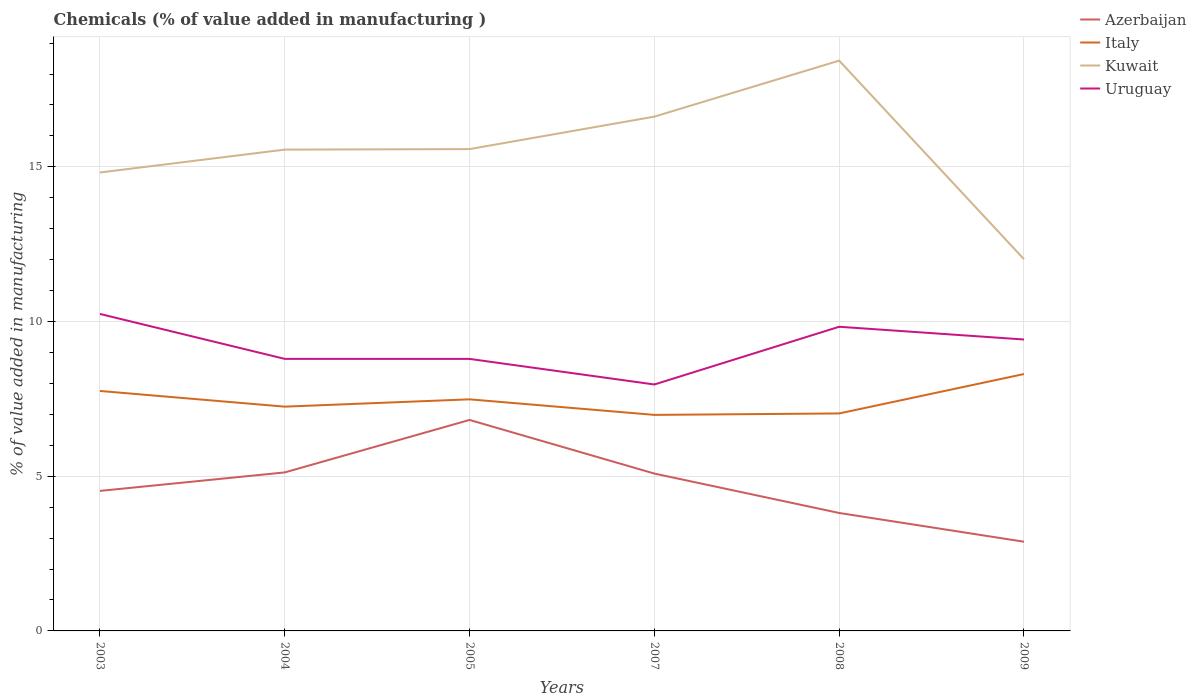How many different coloured lines are there?
Ensure brevity in your answer.  4. Does the line corresponding to Azerbaijan intersect with the line corresponding to Uruguay?
Offer a terse response. No. Across all years, what is the maximum value added in manufacturing chemicals in Kuwait?
Keep it short and to the point. 12.02. What is the total value added in manufacturing chemicals in Kuwait in the graph?
Make the answer very short. 2.8. What is the difference between the highest and the second highest value added in manufacturing chemicals in Italy?
Your response must be concise. 1.32. What is the difference between the highest and the lowest value added in manufacturing chemicals in Azerbaijan?
Offer a very short reply. 3. Is the value added in manufacturing chemicals in Kuwait strictly greater than the value added in manufacturing chemicals in Uruguay over the years?
Your response must be concise. No. How many lines are there?
Give a very brief answer. 4. What is the difference between two consecutive major ticks on the Y-axis?
Offer a very short reply. 5. Are the values on the major ticks of Y-axis written in scientific E-notation?
Ensure brevity in your answer.  No. Where does the legend appear in the graph?
Ensure brevity in your answer.  Top right. How many legend labels are there?
Give a very brief answer. 4. What is the title of the graph?
Ensure brevity in your answer.  Chemicals (% of value added in manufacturing ). Does "Lithuania" appear as one of the legend labels in the graph?
Your answer should be very brief. No. What is the label or title of the Y-axis?
Your response must be concise. % of value added in manufacturing. What is the % of value added in manufacturing of Azerbaijan in 2003?
Your response must be concise. 4.53. What is the % of value added in manufacturing in Italy in 2003?
Your answer should be compact. 7.76. What is the % of value added in manufacturing in Kuwait in 2003?
Make the answer very short. 14.82. What is the % of value added in manufacturing of Uruguay in 2003?
Provide a short and direct response. 10.25. What is the % of value added in manufacturing of Azerbaijan in 2004?
Offer a very short reply. 5.12. What is the % of value added in manufacturing of Italy in 2004?
Ensure brevity in your answer.  7.25. What is the % of value added in manufacturing in Kuwait in 2004?
Provide a short and direct response. 15.56. What is the % of value added in manufacturing in Uruguay in 2004?
Make the answer very short. 8.79. What is the % of value added in manufacturing in Azerbaijan in 2005?
Ensure brevity in your answer.  6.82. What is the % of value added in manufacturing of Italy in 2005?
Your response must be concise. 7.49. What is the % of value added in manufacturing of Kuwait in 2005?
Provide a short and direct response. 15.57. What is the % of value added in manufacturing in Uruguay in 2005?
Your answer should be very brief. 8.79. What is the % of value added in manufacturing of Azerbaijan in 2007?
Your answer should be compact. 5.09. What is the % of value added in manufacturing of Italy in 2007?
Keep it short and to the point. 6.98. What is the % of value added in manufacturing of Kuwait in 2007?
Your answer should be very brief. 16.62. What is the % of value added in manufacturing in Uruguay in 2007?
Make the answer very short. 7.97. What is the % of value added in manufacturing in Azerbaijan in 2008?
Keep it short and to the point. 3.81. What is the % of value added in manufacturing in Italy in 2008?
Keep it short and to the point. 7.03. What is the % of value added in manufacturing in Kuwait in 2008?
Make the answer very short. 18.43. What is the % of value added in manufacturing in Uruguay in 2008?
Your answer should be very brief. 9.83. What is the % of value added in manufacturing in Azerbaijan in 2009?
Your answer should be compact. 2.88. What is the % of value added in manufacturing of Italy in 2009?
Your response must be concise. 8.3. What is the % of value added in manufacturing of Kuwait in 2009?
Provide a short and direct response. 12.02. What is the % of value added in manufacturing in Uruguay in 2009?
Make the answer very short. 9.42. Across all years, what is the maximum % of value added in manufacturing in Azerbaijan?
Your answer should be very brief. 6.82. Across all years, what is the maximum % of value added in manufacturing in Italy?
Make the answer very short. 8.3. Across all years, what is the maximum % of value added in manufacturing of Kuwait?
Keep it short and to the point. 18.43. Across all years, what is the maximum % of value added in manufacturing of Uruguay?
Your answer should be very brief. 10.25. Across all years, what is the minimum % of value added in manufacturing in Azerbaijan?
Provide a short and direct response. 2.88. Across all years, what is the minimum % of value added in manufacturing of Italy?
Your answer should be very brief. 6.98. Across all years, what is the minimum % of value added in manufacturing of Kuwait?
Give a very brief answer. 12.02. Across all years, what is the minimum % of value added in manufacturing of Uruguay?
Offer a terse response. 7.97. What is the total % of value added in manufacturing in Azerbaijan in the graph?
Make the answer very short. 28.25. What is the total % of value added in manufacturing in Italy in the graph?
Give a very brief answer. 44.81. What is the total % of value added in manufacturing in Kuwait in the graph?
Provide a short and direct response. 93.02. What is the total % of value added in manufacturing in Uruguay in the graph?
Provide a succinct answer. 55.05. What is the difference between the % of value added in manufacturing of Azerbaijan in 2003 and that in 2004?
Ensure brevity in your answer.  -0.6. What is the difference between the % of value added in manufacturing in Italy in 2003 and that in 2004?
Give a very brief answer. 0.51. What is the difference between the % of value added in manufacturing in Kuwait in 2003 and that in 2004?
Ensure brevity in your answer.  -0.74. What is the difference between the % of value added in manufacturing in Uruguay in 2003 and that in 2004?
Your answer should be compact. 1.45. What is the difference between the % of value added in manufacturing of Azerbaijan in 2003 and that in 2005?
Your answer should be compact. -2.29. What is the difference between the % of value added in manufacturing in Italy in 2003 and that in 2005?
Your response must be concise. 0.27. What is the difference between the % of value added in manufacturing in Kuwait in 2003 and that in 2005?
Offer a terse response. -0.76. What is the difference between the % of value added in manufacturing of Uruguay in 2003 and that in 2005?
Ensure brevity in your answer.  1.45. What is the difference between the % of value added in manufacturing of Azerbaijan in 2003 and that in 2007?
Offer a terse response. -0.56. What is the difference between the % of value added in manufacturing in Italy in 2003 and that in 2007?
Make the answer very short. 0.77. What is the difference between the % of value added in manufacturing in Kuwait in 2003 and that in 2007?
Offer a very short reply. -1.81. What is the difference between the % of value added in manufacturing in Uruguay in 2003 and that in 2007?
Offer a terse response. 2.28. What is the difference between the % of value added in manufacturing in Azerbaijan in 2003 and that in 2008?
Your answer should be very brief. 0.71. What is the difference between the % of value added in manufacturing in Italy in 2003 and that in 2008?
Give a very brief answer. 0.73. What is the difference between the % of value added in manufacturing in Kuwait in 2003 and that in 2008?
Your answer should be very brief. -3.62. What is the difference between the % of value added in manufacturing of Uruguay in 2003 and that in 2008?
Provide a succinct answer. 0.41. What is the difference between the % of value added in manufacturing in Azerbaijan in 2003 and that in 2009?
Make the answer very short. 1.64. What is the difference between the % of value added in manufacturing of Italy in 2003 and that in 2009?
Offer a very short reply. -0.55. What is the difference between the % of value added in manufacturing in Kuwait in 2003 and that in 2009?
Your answer should be compact. 2.8. What is the difference between the % of value added in manufacturing in Uruguay in 2003 and that in 2009?
Your response must be concise. 0.83. What is the difference between the % of value added in manufacturing of Azerbaijan in 2004 and that in 2005?
Offer a terse response. -1.7. What is the difference between the % of value added in manufacturing of Italy in 2004 and that in 2005?
Keep it short and to the point. -0.24. What is the difference between the % of value added in manufacturing in Kuwait in 2004 and that in 2005?
Offer a very short reply. -0.02. What is the difference between the % of value added in manufacturing of Uruguay in 2004 and that in 2005?
Provide a short and direct response. 0. What is the difference between the % of value added in manufacturing in Azerbaijan in 2004 and that in 2007?
Offer a very short reply. 0.04. What is the difference between the % of value added in manufacturing in Italy in 2004 and that in 2007?
Ensure brevity in your answer.  0.27. What is the difference between the % of value added in manufacturing in Kuwait in 2004 and that in 2007?
Offer a very short reply. -1.07. What is the difference between the % of value added in manufacturing of Uruguay in 2004 and that in 2007?
Keep it short and to the point. 0.83. What is the difference between the % of value added in manufacturing of Azerbaijan in 2004 and that in 2008?
Offer a terse response. 1.31. What is the difference between the % of value added in manufacturing in Italy in 2004 and that in 2008?
Offer a terse response. 0.22. What is the difference between the % of value added in manufacturing in Kuwait in 2004 and that in 2008?
Make the answer very short. -2.88. What is the difference between the % of value added in manufacturing of Uruguay in 2004 and that in 2008?
Provide a succinct answer. -1.04. What is the difference between the % of value added in manufacturing in Azerbaijan in 2004 and that in 2009?
Provide a short and direct response. 2.24. What is the difference between the % of value added in manufacturing of Italy in 2004 and that in 2009?
Offer a very short reply. -1.05. What is the difference between the % of value added in manufacturing of Kuwait in 2004 and that in 2009?
Your answer should be compact. 3.54. What is the difference between the % of value added in manufacturing in Uruguay in 2004 and that in 2009?
Provide a short and direct response. -0.63. What is the difference between the % of value added in manufacturing of Azerbaijan in 2005 and that in 2007?
Keep it short and to the point. 1.73. What is the difference between the % of value added in manufacturing in Italy in 2005 and that in 2007?
Your answer should be very brief. 0.5. What is the difference between the % of value added in manufacturing of Kuwait in 2005 and that in 2007?
Provide a short and direct response. -1.05. What is the difference between the % of value added in manufacturing of Uruguay in 2005 and that in 2007?
Offer a very short reply. 0.83. What is the difference between the % of value added in manufacturing of Azerbaijan in 2005 and that in 2008?
Your answer should be compact. 3.01. What is the difference between the % of value added in manufacturing in Italy in 2005 and that in 2008?
Make the answer very short. 0.46. What is the difference between the % of value added in manufacturing of Kuwait in 2005 and that in 2008?
Your answer should be very brief. -2.86. What is the difference between the % of value added in manufacturing in Uruguay in 2005 and that in 2008?
Your answer should be very brief. -1.04. What is the difference between the % of value added in manufacturing in Azerbaijan in 2005 and that in 2009?
Provide a short and direct response. 3.94. What is the difference between the % of value added in manufacturing in Italy in 2005 and that in 2009?
Provide a short and direct response. -0.82. What is the difference between the % of value added in manufacturing in Kuwait in 2005 and that in 2009?
Give a very brief answer. 3.56. What is the difference between the % of value added in manufacturing of Uruguay in 2005 and that in 2009?
Keep it short and to the point. -0.63. What is the difference between the % of value added in manufacturing of Azerbaijan in 2007 and that in 2008?
Make the answer very short. 1.27. What is the difference between the % of value added in manufacturing in Italy in 2007 and that in 2008?
Provide a succinct answer. -0.05. What is the difference between the % of value added in manufacturing of Kuwait in 2007 and that in 2008?
Make the answer very short. -1.81. What is the difference between the % of value added in manufacturing of Uruguay in 2007 and that in 2008?
Offer a very short reply. -1.87. What is the difference between the % of value added in manufacturing in Azerbaijan in 2007 and that in 2009?
Your answer should be compact. 2.2. What is the difference between the % of value added in manufacturing of Italy in 2007 and that in 2009?
Make the answer very short. -1.32. What is the difference between the % of value added in manufacturing of Kuwait in 2007 and that in 2009?
Ensure brevity in your answer.  4.61. What is the difference between the % of value added in manufacturing in Uruguay in 2007 and that in 2009?
Your response must be concise. -1.45. What is the difference between the % of value added in manufacturing in Azerbaijan in 2008 and that in 2009?
Your response must be concise. 0.93. What is the difference between the % of value added in manufacturing in Italy in 2008 and that in 2009?
Your response must be concise. -1.27. What is the difference between the % of value added in manufacturing in Kuwait in 2008 and that in 2009?
Give a very brief answer. 6.42. What is the difference between the % of value added in manufacturing of Uruguay in 2008 and that in 2009?
Offer a terse response. 0.41. What is the difference between the % of value added in manufacturing of Azerbaijan in 2003 and the % of value added in manufacturing of Italy in 2004?
Your answer should be compact. -2.72. What is the difference between the % of value added in manufacturing in Azerbaijan in 2003 and the % of value added in manufacturing in Kuwait in 2004?
Provide a short and direct response. -11.03. What is the difference between the % of value added in manufacturing of Azerbaijan in 2003 and the % of value added in manufacturing of Uruguay in 2004?
Your answer should be very brief. -4.27. What is the difference between the % of value added in manufacturing of Italy in 2003 and the % of value added in manufacturing of Kuwait in 2004?
Offer a terse response. -7.8. What is the difference between the % of value added in manufacturing in Italy in 2003 and the % of value added in manufacturing in Uruguay in 2004?
Give a very brief answer. -1.04. What is the difference between the % of value added in manufacturing of Kuwait in 2003 and the % of value added in manufacturing of Uruguay in 2004?
Keep it short and to the point. 6.02. What is the difference between the % of value added in manufacturing of Azerbaijan in 2003 and the % of value added in manufacturing of Italy in 2005?
Give a very brief answer. -2.96. What is the difference between the % of value added in manufacturing of Azerbaijan in 2003 and the % of value added in manufacturing of Kuwait in 2005?
Give a very brief answer. -11.05. What is the difference between the % of value added in manufacturing in Azerbaijan in 2003 and the % of value added in manufacturing in Uruguay in 2005?
Give a very brief answer. -4.27. What is the difference between the % of value added in manufacturing of Italy in 2003 and the % of value added in manufacturing of Kuwait in 2005?
Make the answer very short. -7.82. What is the difference between the % of value added in manufacturing in Italy in 2003 and the % of value added in manufacturing in Uruguay in 2005?
Ensure brevity in your answer.  -1.04. What is the difference between the % of value added in manufacturing in Kuwait in 2003 and the % of value added in manufacturing in Uruguay in 2005?
Give a very brief answer. 6.03. What is the difference between the % of value added in manufacturing in Azerbaijan in 2003 and the % of value added in manufacturing in Italy in 2007?
Offer a terse response. -2.46. What is the difference between the % of value added in manufacturing in Azerbaijan in 2003 and the % of value added in manufacturing in Kuwait in 2007?
Provide a succinct answer. -12.1. What is the difference between the % of value added in manufacturing in Azerbaijan in 2003 and the % of value added in manufacturing in Uruguay in 2007?
Make the answer very short. -3.44. What is the difference between the % of value added in manufacturing of Italy in 2003 and the % of value added in manufacturing of Kuwait in 2007?
Keep it short and to the point. -8.87. What is the difference between the % of value added in manufacturing in Italy in 2003 and the % of value added in manufacturing in Uruguay in 2007?
Offer a very short reply. -0.21. What is the difference between the % of value added in manufacturing in Kuwait in 2003 and the % of value added in manufacturing in Uruguay in 2007?
Provide a short and direct response. 6.85. What is the difference between the % of value added in manufacturing of Azerbaijan in 2003 and the % of value added in manufacturing of Italy in 2008?
Offer a very short reply. -2.5. What is the difference between the % of value added in manufacturing of Azerbaijan in 2003 and the % of value added in manufacturing of Kuwait in 2008?
Make the answer very short. -13.91. What is the difference between the % of value added in manufacturing of Azerbaijan in 2003 and the % of value added in manufacturing of Uruguay in 2008?
Your response must be concise. -5.31. What is the difference between the % of value added in manufacturing in Italy in 2003 and the % of value added in manufacturing in Kuwait in 2008?
Your response must be concise. -10.68. What is the difference between the % of value added in manufacturing of Italy in 2003 and the % of value added in manufacturing of Uruguay in 2008?
Give a very brief answer. -2.08. What is the difference between the % of value added in manufacturing of Kuwait in 2003 and the % of value added in manufacturing of Uruguay in 2008?
Provide a succinct answer. 4.99. What is the difference between the % of value added in manufacturing of Azerbaijan in 2003 and the % of value added in manufacturing of Italy in 2009?
Your response must be concise. -3.78. What is the difference between the % of value added in manufacturing in Azerbaijan in 2003 and the % of value added in manufacturing in Kuwait in 2009?
Keep it short and to the point. -7.49. What is the difference between the % of value added in manufacturing in Azerbaijan in 2003 and the % of value added in manufacturing in Uruguay in 2009?
Your answer should be very brief. -4.89. What is the difference between the % of value added in manufacturing of Italy in 2003 and the % of value added in manufacturing of Kuwait in 2009?
Your answer should be compact. -4.26. What is the difference between the % of value added in manufacturing in Italy in 2003 and the % of value added in manufacturing in Uruguay in 2009?
Your answer should be very brief. -1.66. What is the difference between the % of value added in manufacturing of Kuwait in 2003 and the % of value added in manufacturing of Uruguay in 2009?
Your response must be concise. 5.4. What is the difference between the % of value added in manufacturing in Azerbaijan in 2004 and the % of value added in manufacturing in Italy in 2005?
Your response must be concise. -2.36. What is the difference between the % of value added in manufacturing in Azerbaijan in 2004 and the % of value added in manufacturing in Kuwait in 2005?
Offer a very short reply. -10.45. What is the difference between the % of value added in manufacturing of Azerbaijan in 2004 and the % of value added in manufacturing of Uruguay in 2005?
Provide a succinct answer. -3.67. What is the difference between the % of value added in manufacturing of Italy in 2004 and the % of value added in manufacturing of Kuwait in 2005?
Your answer should be very brief. -8.33. What is the difference between the % of value added in manufacturing in Italy in 2004 and the % of value added in manufacturing in Uruguay in 2005?
Your answer should be very brief. -1.54. What is the difference between the % of value added in manufacturing in Kuwait in 2004 and the % of value added in manufacturing in Uruguay in 2005?
Your answer should be compact. 6.77. What is the difference between the % of value added in manufacturing of Azerbaijan in 2004 and the % of value added in manufacturing of Italy in 2007?
Offer a very short reply. -1.86. What is the difference between the % of value added in manufacturing of Azerbaijan in 2004 and the % of value added in manufacturing of Kuwait in 2007?
Your answer should be very brief. -11.5. What is the difference between the % of value added in manufacturing in Azerbaijan in 2004 and the % of value added in manufacturing in Uruguay in 2007?
Provide a succinct answer. -2.84. What is the difference between the % of value added in manufacturing of Italy in 2004 and the % of value added in manufacturing of Kuwait in 2007?
Give a very brief answer. -9.37. What is the difference between the % of value added in manufacturing in Italy in 2004 and the % of value added in manufacturing in Uruguay in 2007?
Provide a succinct answer. -0.72. What is the difference between the % of value added in manufacturing of Kuwait in 2004 and the % of value added in manufacturing of Uruguay in 2007?
Your answer should be very brief. 7.59. What is the difference between the % of value added in manufacturing of Azerbaijan in 2004 and the % of value added in manufacturing of Italy in 2008?
Provide a short and direct response. -1.91. What is the difference between the % of value added in manufacturing of Azerbaijan in 2004 and the % of value added in manufacturing of Kuwait in 2008?
Ensure brevity in your answer.  -13.31. What is the difference between the % of value added in manufacturing of Azerbaijan in 2004 and the % of value added in manufacturing of Uruguay in 2008?
Keep it short and to the point. -4.71. What is the difference between the % of value added in manufacturing in Italy in 2004 and the % of value added in manufacturing in Kuwait in 2008?
Offer a terse response. -11.18. What is the difference between the % of value added in manufacturing in Italy in 2004 and the % of value added in manufacturing in Uruguay in 2008?
Make the answer very short. -2.58. What is the difference between the % of value added in manufacturing of Kuwait in 2004 and the % of value added in manufacturing of Uruguay in 2008?
Your answer should be compact. 5.73. What is the difference between the % of value added in manufacturing in Azerbaijan in 2004 and the % of value added in manufacturing in Italy in 2009?
Make the answer very short. -3.18. What is the difference between the % of value added in manufacturing in Azerbaijan in 2004 and the % of value added in manufacturing in Kuwait in 2009?
Offer a very short reply. -6.89. What is the difference between the % of value added in manufacturing in Azerbaijan in 2004 and the % of value added in manufacturing in Uruguay in 2009?
Provide a succinct answer. -4.3. What is the difference between the % of value added in manufacturing of Italy in 2004 and the % of value added in manufacturing of Kuwait in 2009?
Ensure brevity in your answer.  -4.77. What is the difference between the % of value added in manufacturing in Italy in 2004 and the % of value added in manufacturing in Uruguay in 2009?
Your response must be concise. -2.17. What is the difference between the % of value added in manufacturing of Kuwait in 2004 and the % of value added in manufacturing of Uruguay in 2009?
Offer a terse response. 6.14. What is the difference between the % of value added in manufacturing of Azerbaijan in 2005 and the % of value added in manufacturing of Italy in 2007?
Keep it short and to the point. -0.16. What is the difference between the % of value added in manufacturing of Azerbaijan in 2005 and the % of value added in manufacturing of Kuwait in 2007?
Your response must be concise. -9.8. What is the difference between the % of value added in manufacturing of Azerbaijan in 2005 and the % of value added in manufacturing of Uruguay in 2007?
Your answer should be compact. -1.15. What is the difference between the % of value added in manufacturing of Italy in 2005 and the % of value added in manufacturing of Kuwait in 2007?
Provide a short and direct response. -9.14. What is the difference between the % of value added in manufacturing of Italy in 2005 and the % of value added in manufacturing of Uruguay in 2007?
Ensure brevity in your answer.  -0.48. What is the difference between the % of value added in manufacturing of Kuwait in 2005 and the % of value added in manufacturing of Uruguay in 2007?
Offer a very short reply. 7.61. What is the difference between the % of value added in manufacturing of Azerbaijan in 2005 and the % of value added in manufacturing of Italy in 2008?
Provide a succinct answer. -0.21. What is the difference between the % of value added in manufacturing in Azerbaijan in 2005 and the % of value added in manufacturing in Kuwait in 2008?
Offer a terse response. -11.61. What is the difference between the % of value added in manufacturing in Azerbaijan in 2005 and the % of value added in manufacturing in Uruguay in 2008?
Your response must be concise. -3.01. What is the difference between the % of value added in manufacturing of Italy in 2005 and the % of value added in manufacturing of Kuwait in 2008?
Offer a terse response. -10.95. What is the difference between the % of value added in manufacturing in Italy in 2005 and the % of value added in manufacturing in Uruguay in 2008?
Make the answer very short. -2.35. What is the difference between the % of value added in manufacturing of Kuwait in 2005 and the % of value added in manufacturing of Uruguay in 2008?
Provide a short and direct response. 5.74. What is the difference between the % of value added in manufacturing of Azerbaijan in 2005 and the % of value added in manufacturing of Italy in 2009?
Give a very brief answer. -1.48. What is the difference between the % of value added in manufacturing of Azerbaijan in 2005 and the % of value added in manufacturing of Kuwait in 2009?
Make the answer very short. -5.2. What is the difference between the % of value added in manufacturing in Azerbaijan in 2005 and the % of value added in manufacturing in Uruguay in 2009?
Your response must be concise. -2.6. What is the difference between the % of value added in manufacturing of Italy in 2005 and the % of value added in manufacturing of Kuwait in 2009?
Provide a short and direct response. -4.53. What is the difference between the % of value added in manufacturing of Italy in 2005 and the % of value added in manufacturing of Uruguay in 2009?
Keep it short and to the point. -1.93. What is the difference between the % of value added in manufacturing of Kuwait in 2005 and the % of value added in manufacturing of Uruguay in 2009?
Your answer should be very brief. 6.15. What is the difference between the % of value added in manufacturing in Azerbaijan in 2007 and the % of value added in manufacturing in Italy in 2008?
Keep it short and to the point. -1.94. What is the difference between the % of value added in manufacturing of Azerbaijan in 2007 and the % of value added in manufacturing of Kuwait in 2008?
Offer a very short reply. -13.35. What is the difference between the % of value added in manufacturing in Azerbaijan in 2007 and the % of value added in manufacturing in Uruguay in 2008?
Provide a short and direct response. -4.74. What is the difference between the % of value added in manufacturing in Italy in 2007 and the % of value added in manufacturing in Kuwait in 2008?
Your response must be concise. -11.45. What is the difference between the % of value added in manufacturing in Italy in 2007 and the % of value added in manufacturing in Uruguay in 2008?
Provide a short and direct response. -2.85. What is the difference between the % of value added in manufacturing in Kuwait in 2007 and the % of value added in manufacturing in Uruguay in 2008?
Keep it short and to the point. 6.79. What is the difference between the % of value added in manufacturing of Azerbaijan in 2007 and the % of value added in manufacturing of Italy in 2009?
Give a very brief answer. -3.22. What is the difference between the % of value added in manufacturing of Azerbaijan in 2007 and the % of value added in manufacturing of Kuwait in 2009?
Give a very brief answer. -6.93. What is the difference between the % of value added in manufacturing of Azerbaijan in 2007 and the % of value added in manufacturing of Uruguay in 2009?
Your response must be concise. -4.33. What is the difference between the % of value added in manufacturing in Italy in 2007 and the % of value added in manufacturing in Kuwait in 2009?
Ensure brevity in your answer.  -5.03. What is the difference between the % of value added in manufacturing in Italy in 2007 and the % of value added in manufacturing in Uruguay in 2009?
Your answer should be very brief. -2.44. What is the difference between the % of value added in manufacturing of Kuwait in 2007 and the % of value added in manufacturing of Uruguay in 2009?
Give a very brief answer. 7.2. What is the difference between the % of value added in manufacturing in Azerbaijan in 2008 and the % of value added in manufacturing in Italy in 2009?
Offer a very short reply. -4.49. What is the difference between the % of value added in manufacturing in Azerbaijan in 2008 and the % of value added in manufacturing in Kuwait in 2009?
Provide a succinct answer. -8.2. What is the difference between the % of value added in manufacturing in Azerbaijan in 2008 and the % of value added in manufacturing in Uruguay in 2009?
Your answer should be compact. -5.61. What is the difference between the % of value added in manufacturing in Italy in 2008 and the % of value added in manufacturing in Kuwait in 2009?
Offer a terse response. -4.99. What is the difference between the % of value added in manufacturing of Italy in 2008 and the % of value added in manufacturing of Uruguay in 2009?
Provide a succinct answer. -2.39. What is the difference between the % of value added in manufacturing in Kuwait in 2008 and the % of value added in manufacturing in Uruguay in 2009?
Offer a very short reply. 9.01. What is the average % of value added in manufacturing of Azerbaijan per year?
Offer a terse response. 4.71. What is the average % of value added in manufacturing of Italy per year?
Provide a short and direct response. 7.47. What is the average % of value added in manufacturing of Kuwait per year?
Offer a very short reply. 15.5. What is the average % of value added in manufacturing of Uruguay per year?
Ensure brevity in your answer.  9.17. In the year 2003, what is the difference between the % of value added in manufacturing in Azerbaijan and % of value added in manufacturing in Italy?
Your answer should be very brief. -3.23. In the year 2003, what is the difference between the % of value added in manufacturing of Azerbaijan and % of value added in manufacturing of Kuwait?
Offer a very short reply. -10.29. In the year 2003, what is the difference between the % of value added in manufacturing in Azerbaijan and % of value added in manufacturing in Uruguay?
Your answer should be very brief. -5.72. In the year 2003, what is the difference between the % of value added in manufacturing in Italy and % of value added in manufacturing in Kuwait?
Keep it short and to the point. -7.06. In the year 2003, what is the difference between the % of value added in manufacturing in Italy and % of value added in manufacturing in Uruguay?
Make the answer very short. -2.49. In the year 2003, what is the difference between the % of value added in manufacturing in Kuwait and % of value added in manufacturing in Uruguay?
Your response must be concise. 4.57. In the year 2004, what is the difference between the % of value added in manufacturing of Azerbaijan and % of value added in manufacturing of Italy?
Make the answer very short. -2.13. In the year 2004, what is the difference between the % of value added in manufacturing of Azerbaijan and % of value added in manufacturing of Kuwait?
Offer a terse response. -10.43. In the year 2004, what is the difference between the % of value added in manufacturing of Azerbaijan and % of value added in manufacturing of Uruguay?
Provide a succinct answer. -3.67. In the year 2004, what is the difference between the % of value added in manufacturing in Italy and % of value added in manufacturing in Kuwait?
Ensure brevity in your answer.  -8.31. In the year 2004, what is the difference between the % of value added in manufacturing of Italy and % of value added in manufacturing of Uruguay?
Ensure brevity in your answer.  -1.54. In the year 2004, what is the difference between the % of value added in manufacturing of Kuwait and % of value added in manufacturing of Uruguay?
Your response must be concise. 6.76. In the year 2005, what is the difference between the % of value added in manufacturing in Azerbaijan and % of value added in manufacturing in Italy?
Provide a short and direct response. -0.67. In the year 2005, what is the difference between the % of value added in manufacturing of Azerbaijan and % of value added in manufacturing of Kuwait?
Your answer should be very brief. -8.76. In the year 2005, what is the difference between the % of value added in manufacturing of Azerbaijan and % of value added in manufacturing of Uruguay?
Offer a very short reply. -1.97. In the year 2005, what is the difference between the % of value added in manufacturing in Italy and % of value added in manufacturing in Kuwait?
Your answer should be compact. -8.09. In the year 2005, what is the difference between the % of value added in manufacturing of Italy and % of value added in manufacturing of Uruguay?
Your answer should be compact. -1.31. In the year 2005, what is the difference between the % of value added in manufacturing in Kuwait and % of value added in manufacturing in Uruguay?
Keep it short and to the point. 6.78. In the year 2007, what is the difference between the % of value added in manufacturing in Azerbaijan and % of value added in manufacturing in Italy?
Provide a short and direct response. -1.9. In the year 2007, what is the difference between the % of value added in manufacturing of Azerbaijan and % of value added in manufacturing of Kuwait?
Provide a short and direct response. -11.54. In the year 2007, what is the difference between the % of value added in manufacturing of Azerbaijan and % of value added in manufacturing of Uruguay?
Your answer should be very brief. -2.88. In the year 2007, what is the difference between the % of value added in manufacturing in Italy and % of value added in manufacturing in Kuwait?
Provide a short and direct response. -9.64. In the year 2007, what is the difference between the % of value added in manufacturing of Italy and % of value added in manufacturing of Uruguay?
Provide a succinct answer. -0.98. In the year 2007, what is the difference between the % of value added in manufacturing of Kuwait and % of value added in manufacturing of Uruguay?
Keep it short and to the point. 8.66. In the year 2008, what is the difference between the % of value added in manufacturing in Azerbaijan and % of value added in manufacturing in Italy?
Your answer should be very brief. -3.22. In the year 2008, what is the difference between the % of value added in manufacturing of Azerbaijan and % of value added in manufacturing of Kuwait?
Provide a succinct answer. -14.62. In the year 2008, what is the difference between the % of value added in manufacturing in Azerbaijan and % of value added in manufacturing in Uruguay?
Give a very brief answer. -6.02. In the year 2008, what is the difference between the % of value added in manufacturing in Italy and % of value added in manufacturing in Kuwait?
Give a very brief answer. -11.4. In the year 2008, what is the difference between the % of value added in manufacturing of Italy and % of value added in manufacturing of Uruguay?
Ensure brevity in your answer.  -2.8. In the year 2008, what is the difference between the % of value added in manufacturing in Kuwait and % of value added in manufacturing in Uruguay?
Give a very brief answer. 8.6. In the year 2009, what is the difference between the % of value added in manufacturing in Azerbaijan and % of value added in manufacturing in Italy?
Your response must be concise. -5.42. In the year 2009, what is the difference between the % of value added in manufacturing in Azerbaijan and % of value added in manufacturing in Kuwait?
Keep it short and to the point. -9.13. In the year 2009, what is the difference between the % of value added in manufacturing in Azerbaijan and % of value added in manufacturing in Uruguay?
Your response must be concise. -6.54. In the year 2009, what is the difference between the % of value added in manufacturing of Italy and % of value added in manufacturing of Kuwait?
Make the answer very short. -3.71. In the year 2009, what is the difference between the % of value added in manufacturing in Italy and % of value added in manufacturing in Uruguay?
Ensure brevity in your answer.  -1.12. In the year 2009, what is the difference between the % of value added in manufacturing of Kuwait and % of value added in manufacturing of Uruguay?
Ensure brevity in your answer.  2.6. What is the ratio of the % of value added in manufacturing in Azerbaijan in 2003 to that in 2004?
Provide a succinct answer. 0.88. What is the ratio of the % of value added in manufacturing in Italy in 2003 to that in 2004?
Offer a very short reply. 1.07. What is the ratio of the % of value added in manufacturing in Kuwait in 2003 to that in 2004?
Offer a terse response. 0.95. What is the ratio of the % of value added in manufacturing in Uruguay in 2003 to that in 2004?
Your response must be concise. 1.17. What is the ratio of the % of value added in manufacturing of Azerbaijan in 2003 to that in 2005?
Give a very brief answer. 0.66. What is the ratio of the % of value added in manufacturing of Italy in 2003 to that in 2005?
Your response must be concise. 1.04. What is the ratio of the % of value added in manufacturing in Kuwait in 2003 to that in 2005?
Make the answer very short. 0.95. What is the ratio of the % of value added in manufacturing of Uruguay in 2003 to that in 2005?
Your answer should be very brief. 1.17. What is the ratio of the % of value added in manufacturing in Azerbaijan in 2003 to that in 2007?
Offer a terse response. 0.89. What is the ratio of the % of value added in manufacturing in Italy in 2003 to that in 2007?
Offer a very short reply. 1.11. What is the ratio of the % of value added in manufacturing in Kuwait in 2003 to that in 2007?
Offer a terse response. 0.89. What is the ratio of the % of value added in manufacturing in Uruguay in 2003 to that in 2007?
Your response must be concise. 1.29. What is the ratio of the % of value added in manufacturing of Azerbaijan in 2003 to that in 2008?
Ensure brevity in your answer.  1.19. What is the ratio of the % of value added in manufacturing of Italy in 2003 to that in 2008?
Provide a short and direct response. 1.1. What is the ratio of the % of value added in manufacturing in Kuwait in 2003 to that in 2008?
Give a very brief answer. 0.8. What is the ratio of the % of value added in manufacturing in Uruguay in 2003 to that in 2008?
Keep it short and to the point. 1.04. What is the ratio of the % of value added in manufacturing of Azerbaijan in 2003 to that in 2009?
Keep it short and to the point. 1.57. What is the ratio of the % of value added in manufacturing in Italy in 2003 to that in 2009?
Offer a terse response. 0.93. What is the ratio of the % of value added in manufacturing in Kuwait in 2003 to that in 2009?
Your answer should be compact. 1.23. What is the ratio of the % of value added in manufacturing in Uruguay in 2003 to that in 2009?
Keep it short and to the point. 1.09. What is the ratio of the % of value added in manufacturing of Azerbaijan in 2004 to that in 2005?
Provide a succinct answer. 0.75. What is the ratio of the % of value added in manufacturing of Italy in 2004 to that in 2005?
Keep it short and to the point. 0.97. What is the ratio of the % of value added in manufacturing in Italy in 2004 to that in 2007?
Offer a terse response. 1.04. What is the ratio of the % of value added in manufacturing in Kuwait in 2004 to that in 2007?
Make the answer very short. 0.94. What is the ratio of the % of value added in manufacturing in Uruguay in 2004 to that in 2007?
Your answer should be compact. 1.1. What is the ratio of the % of value added in manufacturing in Azerbaijan in 2004 to that in 2008?
Offer a very short reply. 1.34. What is the ratio of the % of value added in manufacturing in Italy in 2004 to that in 2008?
Offer a terse response. 1.03. What is the ratio of the % of value added in manufacturing of Kuwait in 2004 to that in 2008?
Give a very brief answer. 0.84. What is the ratio of the % of value added in manufacturing in Uruguay in 2004 to that in 2008?
Offer a terse response. 0.89. What is the ratio of the % of value added in manufacturing of Azerbaijan in 2004 to that in 2009?
Provide a succinct answer. 1.78. What is the ratio of the % of value added in manufacturing in Italy in 2004 to that in 2009?
Your answer should be very brief. 0.87. What is the ratio of the % of value added in manufacturing in Kuwait in 2004 to that in 2009?
Provide a short and direct response. 1.29. What is the ratio of the % of value added in manufacturing of Uruguay in 2004 to that in 2009?
Provide a short and direct response. 0.93. What is the ratio of the % of value added in manufacturing in Azerbaijan in 2005 to that in 2007?
Make the answer very short. 1.34. What is the ratio of the % of value added in manufacturing of Italy in 2005 to that in 2007?
Offer a terse response. 1.07. What is the ratio of the % of value added in manufacturing of Kuwait in 2005 to that in 2007?
Provide a succinct answer. 0.94. What is the ratio of the % of value added in manufacturing of Uruguay in 2005 to that in 2007?
Provide a succinct answer. 1.1. What is the ratio of the % of value added in manufacturing in Azerbaijan in 2005 to that in 2008?
Offer a very short reply. 1.79. What is the ratio of the % of value added in manufacturing in Italy in 2005 to that in 2008?
Your answer should be compact. 1.06. What is the ratio of the % of value added in manufacturing in Kuwait in 2005 to that in 2008?
Provide a short and direct response. 0.84. What is the ratio of the % of value added in manufacturing in Uruguay in 2005 to that in 2008?
Make the answer very short. 0.89. What is the ratio of the % of value added in manufacturing in Azerbaijan in 2005 to that in 2009?
Your response must be concise. 2.37. What is the ratio of the % of value added in manufacturing in Italy in 2005 to that in 2009?
Offer a very short reply. 0.9. What is the ratio of the % of value added in manufacturing in Kuwait in 2005 to that in 2009?
Offer a terse response. 1.3. What is the ratio of the % of value added in manufacturing in Uruguay in 2005 to that in 2009?
Ensure brevity in your answer.  0.93. What is the ratio of the % of value added in manufacturing in Azerbaijan in 2007 to that in 2008?
Give a very brief answer. 1.33. What is the ratio of the % of value added in manufacturing in Italy in 2007 to that in 2008?
Keep it short and to the point. 0.99. What is the ratio of the % of value added in manufacturing of Kuwait in 2007 to that in 2008?
Ensure brevity in your answer.  0.9. What is the ratio of the % of value added in manufacturing in Uruguay in 2007 to that in 2008?
Provide a short and direct response. 0.81. What is the ratio of the % of value added in manufacturing in Azerbaijan in 2007 to that in 2009?
Provide a succinct answer. 1.76. What is the ratio of the % of value added in manufacturing in Italy in 2007 to that in 2009?
Offer a terse response. 0.84. What is the ratio of the % of value added in manufacturing in Kuwait in 2007 to that in 2009?
Your response must be concise. 1.38. What is the ratio of the % of value added in manufacturing of Uruguay in 2007 to that in 2009?
Give a very brief answer. 0.85. What is the ratio of the % of value added in manufacturing of Azerbaijan in 2008 to that in 2009?
Offer a very short reply. 1.32. What is the ratio of the % of value added in manufacturing of Italy in 2008 to that in 2009?
Provide a short and direct response. 0.85. What is the ratio of the % of value added in manufacturing in Kuwait in 2008 to that in 2009?
Ensure brevity in your answer.  1.53. What is the ratio of the % of value added in manufacturing in Uruguay in 2008 to that in 2009?
Your answer should be compact. 1.04. What is the difference between the highest and the second highest % of value added in manufacturing in Azerbaijan?
Make the answer very short. 1.7. What is the difference between the highest and the second highest % of value added in manufacturing of Italy?
Offer a very short reply. 0.55. What is the difference between the highest and the second highest % of value added in manufacturing of Kuwait?
Keep it short and to the point. 1.81. What is the difference between the highest and the second highest % of value added in manufacturing of Uruguay?
Provide a succinct answer. 0.41. What is the difference between the highest and the lowest % of value added in manufacturing in Azerbaijan?
Make the answer very short. 3.94. What is the difference between the highest and the lowest % of value added in manufacturing of Italy?
Offer a very short reply. 1.32. What is the difference between the highest and the lowest % of value added in manufacturing of Kuwait?
Offer a terse response. 6.42. What is the difference between the highest and the lowest % of value added in manufacturing of Uruguay?
Your answer should be very brief. 2.28. 